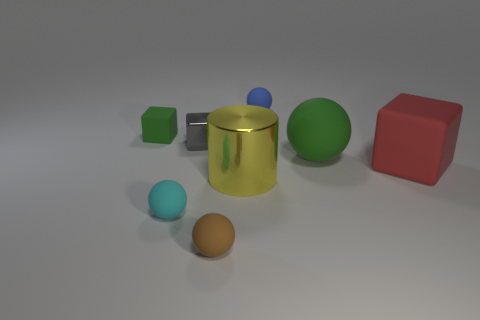How big is the shiny thing that is in front of the rubber cube right of the small blue matte sphere?
Make the answer very short. Large. What is the shape of the big object left of the small blue thing?
Keep it short and to the point. Cylinder. Is the cube that is on the left side of the tiny gray metal thing made of the same material as the green thing that is to the right of the large yellow metal object?
Offer a terse response. Yes. Are there any gray metallic objects that have the same shape as the big red rubber object?
Provide a short and direct response. Yes. What number of things are either big rubber objects that are behind the red cube or tiny brown objects?
Offer a terse response. 2. Are there more small rubber objects that are behind the large matte block than objects to the left of the tiny gray metallic thing?
Your answer should be compact. No. How many metal things are either red blocks or small brown blocks?
Provide a short and direct response. 0. What is the material of the tiny object that is the same color as the big ball?
Your answer should be compact. Rubber. Are there fewer big red matte blocks that are right of the tiny brown matte sphere than tiny matte things that are in front of the tiny gray metal object?
Your response must be concise. Yes. How many things are green balls or matte things that are behind the small green thing?
Provide a short and direct response. 2. 